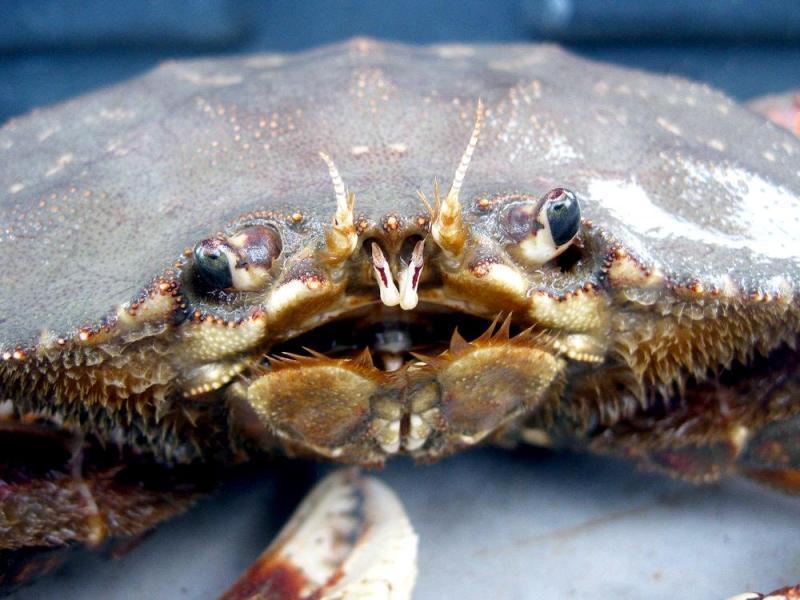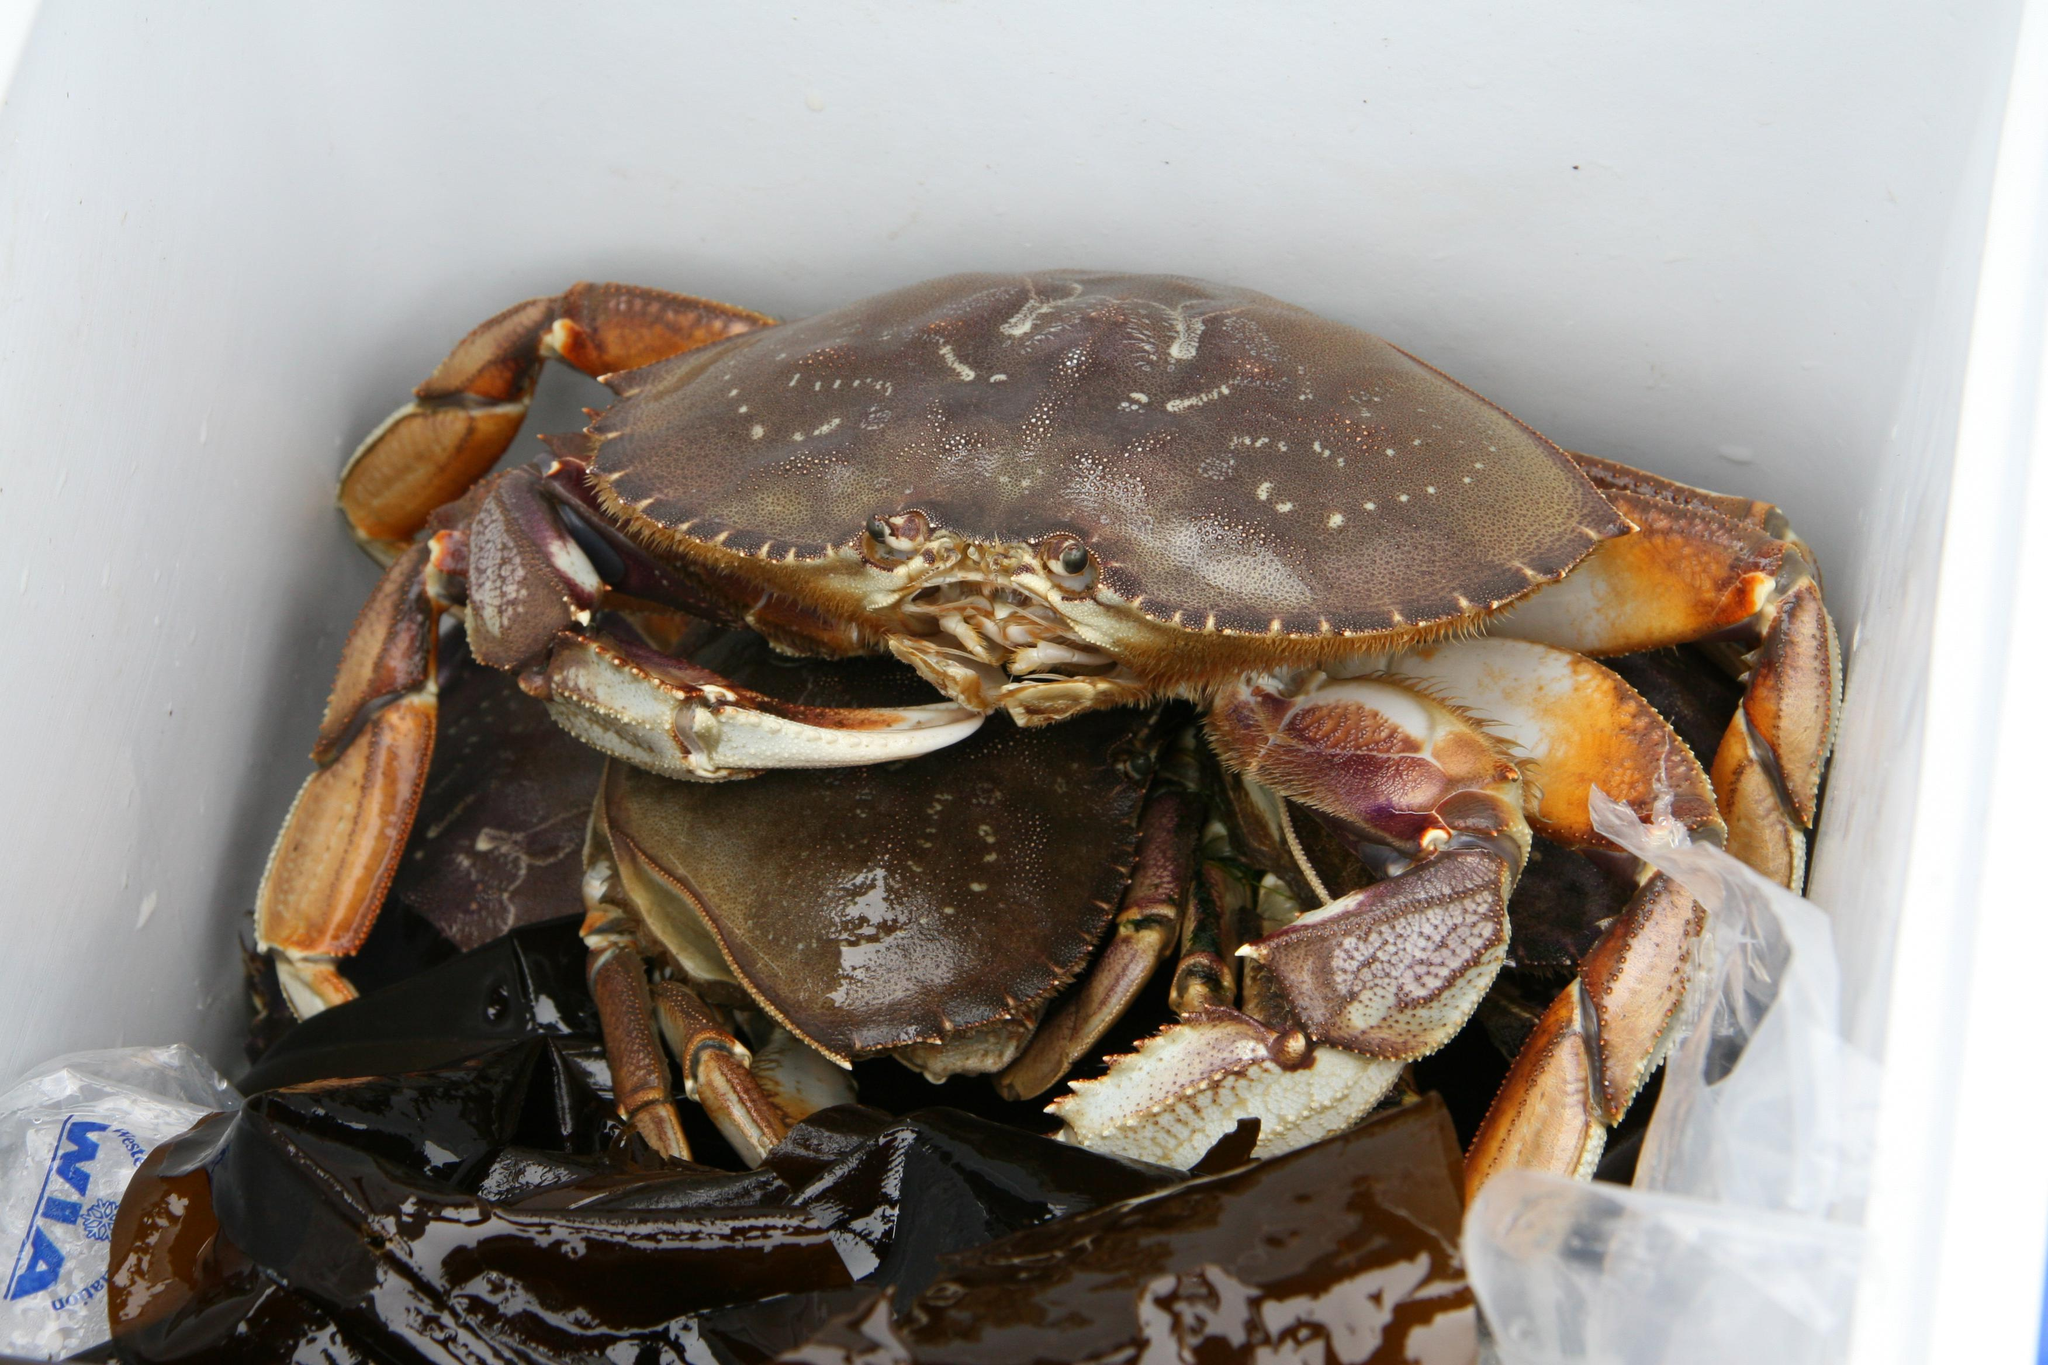The first image is the image on the left, the second image is the image on the right. For the images shown, is this caption "In at least one image there are red colored cooked crabs showing meat ready to be eaten." true? Answer yes or no. No. 